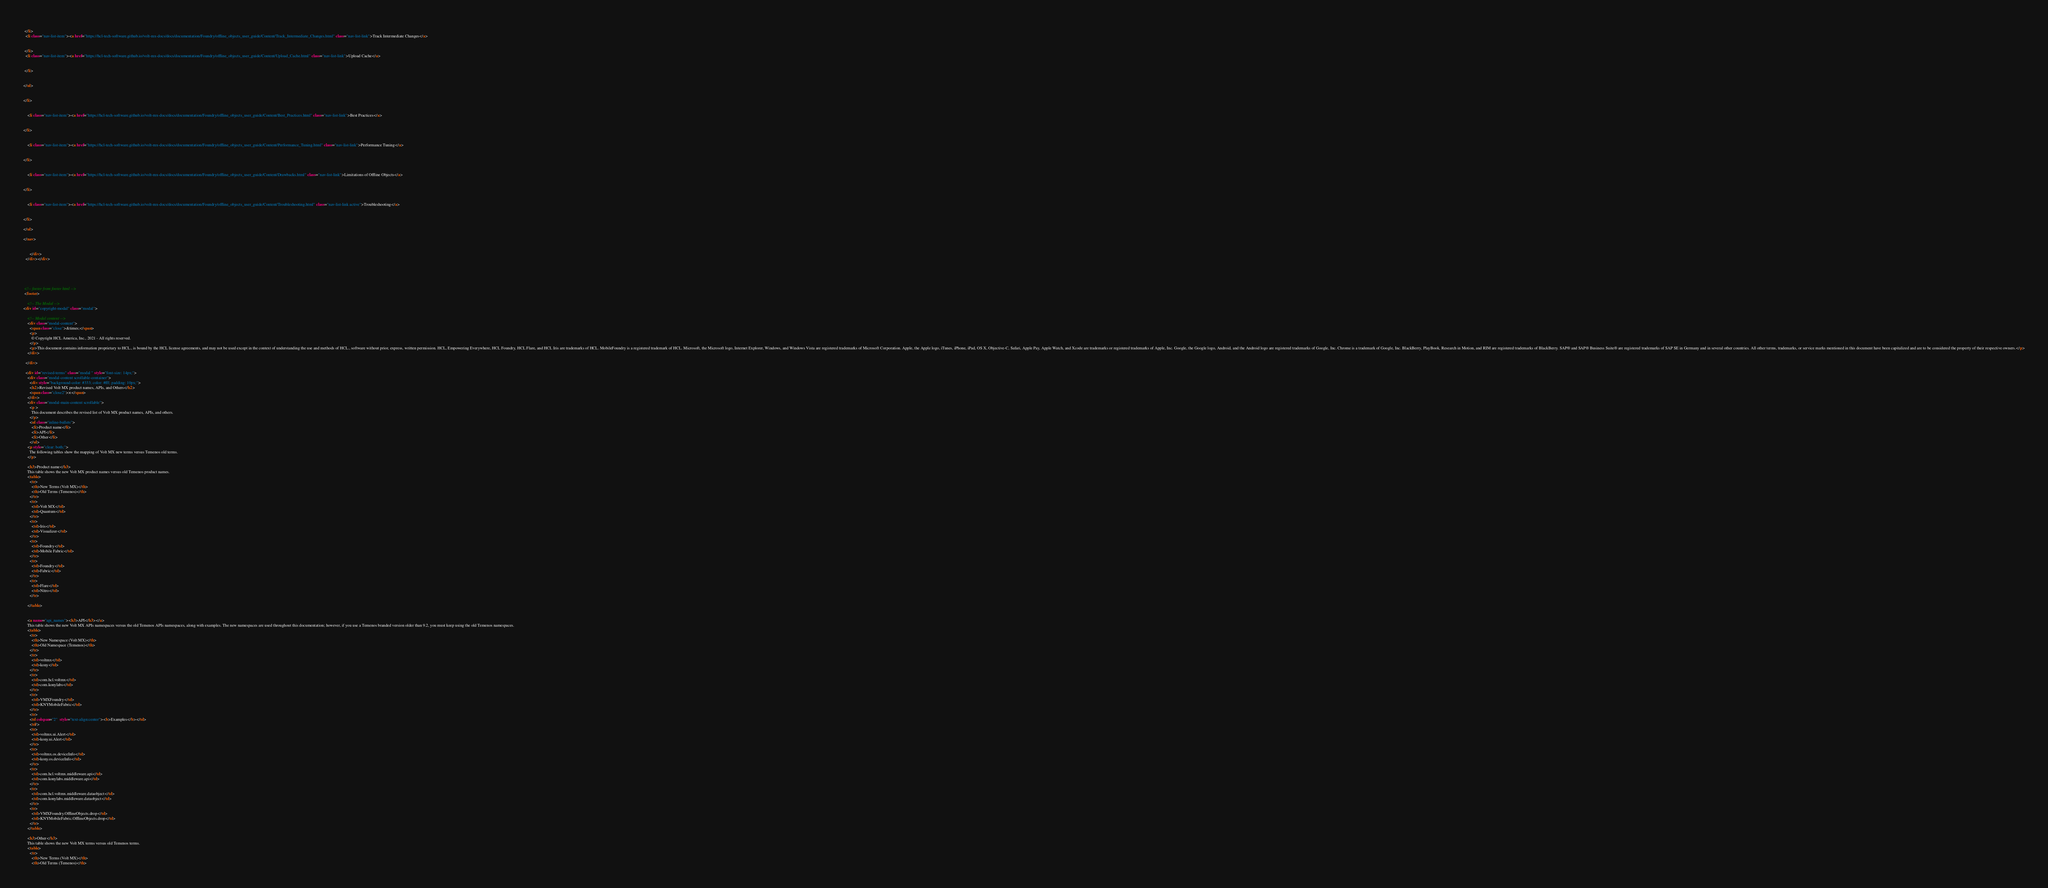<code> <loc_0><loc_0><loc_500><loc_500><_HTML_>
  
 </li>
  <li class="nav-list-item"><a href="https://hcl-tech-software.github.io/volt-mx-docs/docs/documentation/Foundry/offline_objects_user_guide/Content/Track_Intermediate_Changes.html" class="nav-list-link">Track Intermediate Changes</a>

  
 </li>
  <li class="nav-list-item"><a href="https://hcl-tech-software.github.io/volt-mx-docs/docs/documentation/Foundry/offline_objects_user_guide/Content/Upload_Cache.html" class="nav-list-link">Upload Cache</a>

  
 </li>
  

</ul>


</li>


    <li class="nav-list-item"><a href="https://hcl-tech-software.github.io/volt-mx-docs/docs/documentation/Foundry/offline_objects_user_guide/Content/Best_Practices.html" class="nav-list-link">Best Practices</a>
  
      
</li>


    <li class="nav-list-item"><a href="https://hcl-tech-software.github.io/volt-mx-docs/docs/documentation/Foundry/offline_objects_user_guide/Content/Performance_Tuning.html" class="nav-list-link">Performance Tuning</a>
  
      
</li>


    <li class="nav-list-item"><a href="https://hcl-tech-software.github.io/volt-mx-docs/docs/documentation/Foundry/offline_objects_user_guide/Content/Drawbacks.html" class="nav-list-link">Limitations of Offline Objects</a>
  
      
</li>


    <li class="nav-list-item"><a href="https://hcl-tech-software.github.io/volt-mx-docs/docs/documentation/Foundry/offline_objects_user_guide/Content/Troubleshooting.html" class="nav-list-link active">Troubleshooting</a>
  
      
</li>

</ul>

</nav>


      </div>
  </div></div>





 <!-- footer from footer html -->
 <footer>

    <!-- The Modal -->
<div id="copyright-modal" class="modal">

    <!-- Modal content -->
    <div class="modal-content">
      <span class="close">&times;</span>
      <p>
        © Copyright HCL America, Inc., 2021 - All rights reserved.
      </p>
      <p>This document contains information proprietary to HCL., is bound by the HCL license agreements, and may not be used except in the context of understanding the use and methods of HCL., software without prior, express, written permission. HCL, Empowering Everywhere, HCL Foundry, HCL Flare, and HCL Iris are trademarks of HCL. MobileFoundry is a registered trademark of HCL. Microsoft, the Microsoft logo, Internet Explorer, Windows, and Windows Vista are registered trademarks of Microsoft Corporation. Apple, the Apple logo, iTunes, iPhone, iPad, OS X, Objective-C, Safari, Apple Pay, Apple Watch, and Xcode are trademarks or registered trademarks of Apple, Inc. Google, the Google logo, Android, and the Android logo are registered trademarks of Google, Inc. Chrome is a trademark of Google, Inc. BlackBerry, PlayBook, Research in Motion, and RIM are registered trademarks of BlackBerry. SAP® and SAP® Business Suite® are registered trademarks of SAP SE in Germany and in several other countries. All other terms, trademarks, or service marks mentioned in this document have been capitalized and are to be considered the property of their respective owners.</p>
    </div>
  
  </div>

  <div id="revised-terms" class="modal " style="font-size: 14px;">
    <div class="modal-content scrollable-container">
      <div style="background-color: #333; color: #fff; padding: 10px;">
      <h2>Revised Volt MX product names, APIs, and Others</h2>
      <span class="close2">×</span>
    </div>
    <div class="modal-main-content scrollable">
      <p >
        This document describes the revised list of Volt MX product names, APIs, and others.
      </p>
      <ul class="inline-bullets">
        <li>Product name</li>
        <li>API</li>
        <li>Other</li>
      </ul>
    <p style="clear: both;">
      The following tables show the mapping of Volt MX new terms versus Temenos old terms.
    </p>

    <h3>Product name</h3>
    This table shows the new Volt MX product names versus old Temenos product names.
    <table>
      <tr>
        <th>New Terms (Volt MX)</th>
        <th>Old Terms (Temenos)</th>
      </tr>
      <tr>
        <td>Volt MX</td>
        <td>Quantum</td>
      </tr>
      <tr>
        <td>Iris</td>
        <td>Visualizer</td>
      </tr>
      <tr>
        <td>Foundry</td>
        <td>Mobile Fabric</td>
      </tr>
      <tr>
        <td>Foundry</td>
        <td>Fabric</td>
      </tr>
      <tr>
        <td>Flare</td>
        <td>Nitro</td>
      </tr>
      
    </table>


    <a name="api_names"><h3>API</h3></a>
    This table shows the new Volt MX APIs namespaces versus the old Temenos APIs namespaces, along with examples. The new namespaces are used throughout this documentation; however, if you use a Temenos branded version older than 9.2, you must keep using the old Temenos namespaces.
    <table>
      <tr>
        <th>New Namespace (Volt MX)</th>
        <th>Old Namespace (Temenos)</th>
      </tr>
	  <tr>
	    <td>voltmx</td>
		<td>kony</td>
	  </tr>
	  <tr>
	    <td>com.hcl.voltmx</td>
		<td>com.konylabs</td>
	  </tr>
	  <tr>
	    <td>VMXFoundry</td>
		<td>KNYMobileFabric</td>
	  </tr>
	  <tr>
	  <td colspan="2"  style="text-align:center"><b>Examples</b></td>
	  <td/>
      <tr>
        <td>voltmx.ui.Alert</td>
        <td>kony.ui.Alert</td>
      </tr>
      <tr>
        <td>voltmx.os.deviceInfo</td>
        <td>kony.os.deviceInfo</td>
      </tr>
      <tr>
        <td>com.hcl.voltmx.middleware.api</td>
        <td>com.konylabs.middleware.api</td>
      </tr>
      <tr>
        <td>com.hcl.voltmx.middleware.dataobject</td>
        <td>com.konylabs.middleware.dataobject</td>
      </tr>
	  <tr>
	    <td>VMXFoundry.OfflineObjects.drop</td>
		<td>KNYMobileFabric.OfflineObjects.drop</td>
	  </tr>
    </table>

    <h3>Other</h3>
    This table shows the new Volt MX terms versus old Temenos terms.
    <table>
      <tr>
        <th>New Terms (Volt MX)</th>
        <th>Old Terms (Temenos)</th></code> 